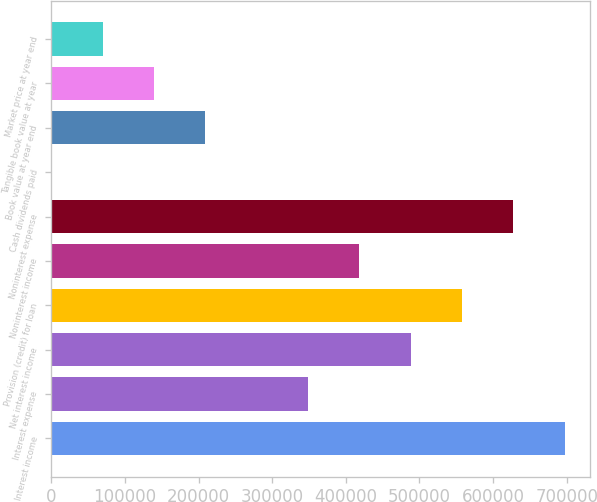Convert chart. <chart><loc_0><loc_0><loc_500><loc_500><bar_chart><fcel>Interest income<fcel>Interest expense<fcel>Net interest income<fcel>Provision (credit) for loan<fcel>Noninterest income<fcel>Noninterest expense<fcel>Cash dividends paid<fcel>Book value at year end<fcel>Tangible book value at year<fcel>Market price at year end<nl><fcel>697155<fcel>348578<fcel>488009<fcel>557724<fcel>418293<fcel>627440<fcel>0.09<fcel>209147<fcel>139431<fcel>69715.6<nl></chart> 